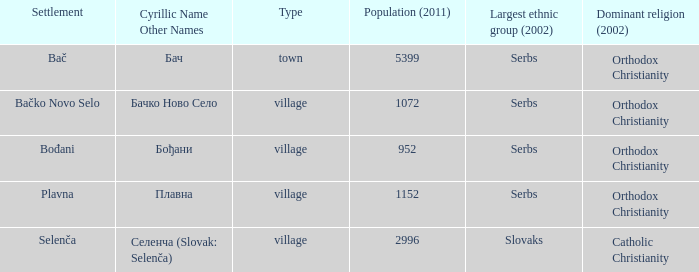What is the tiniest population listed? 952.0. 